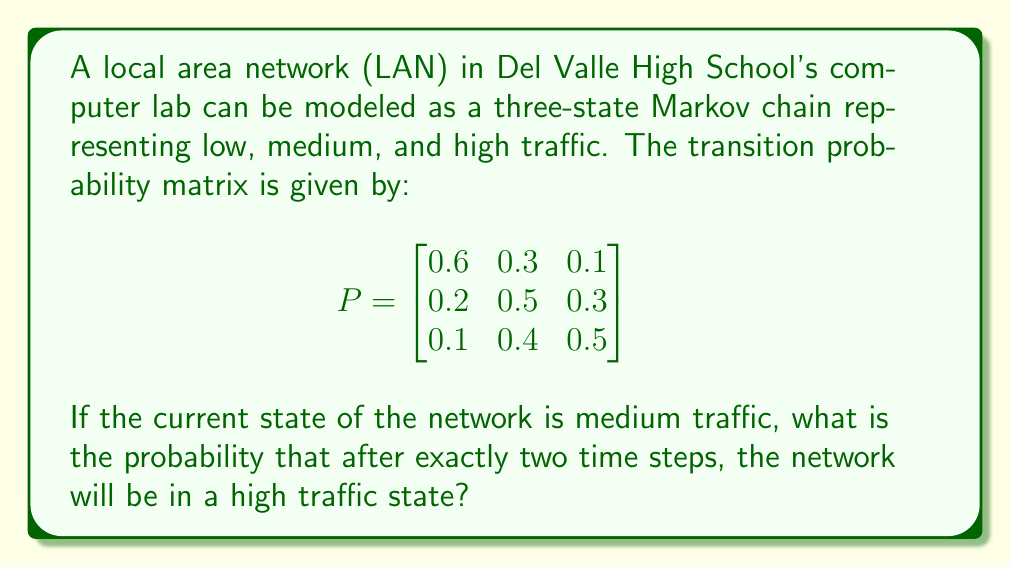Show me your answer to this math problem. Let's approach this step-by-step:

1) We are given the transition probability matrix $P$. The rows represent the current state (low, medium, high) and the columns represent the next state.

2) We start in the medium traffic state, which is the second row of the matrix.

3) To find the probability of being in a specific state after two time steps, we need to multiply the matrix by itself: $P^2$.

4) Let's calculate $P^2$:

   $$P^2 = \begin{bmatrix}
   0.6 & 0.3 & 0.1 \\
   0.2 & 0.5 & 0.3 \\
   0.1 & 0.4 & 0.5
   \end{bmatrix} \times 
   \begin{bmatrix}
   0.6 & 0.3 & 0.1 \\
   0.2 & 0.5 & 0.3 \\
   0.1 & 0.4 & 0.5
   \end{bmatrix}$$

5) Multiplying these matrices:

   $$P^2 = \begin{bmatrix}
   0.43 & 0.39 & 0.18 \\
   0.27 & 0.46 & 0.27 \\
   0.23 & 0.46 & 0.31
   \end{bmatrix}$$

6) We started in the medium traffic state, so we're interested in the second row of $P^2$.

7) The probability of being in a high traffic state after two steps, starting from medium traffic, is the last element of the second row: 0.27.
Answer: 0.27 